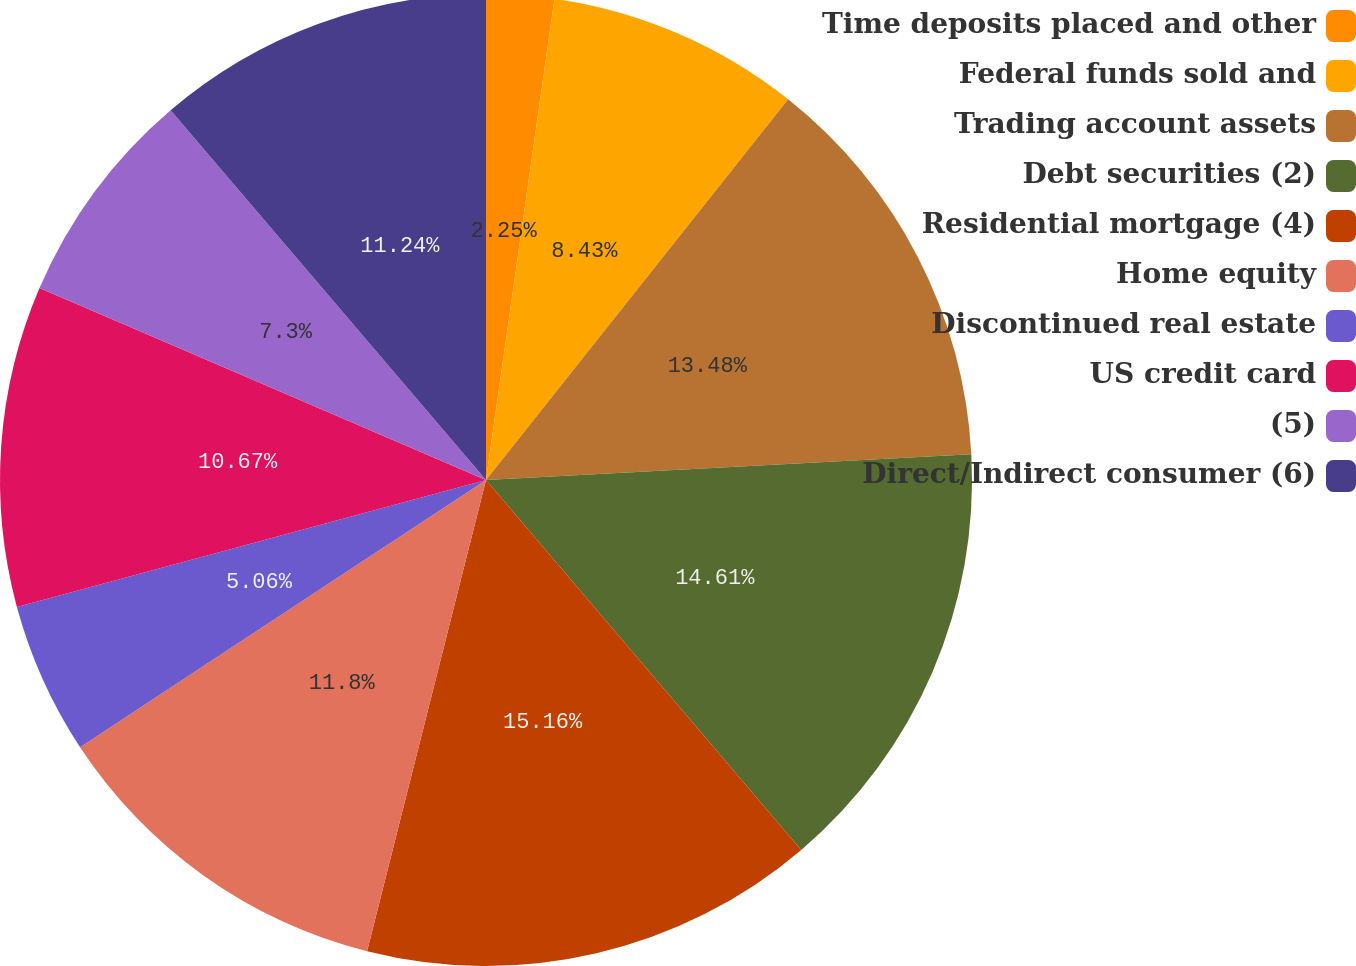Convert chart. <chart><loc_0><loc_0><loc_500><loc_500><pie_chart><fcel>Time deposits placed and other<fcel>Federal funds sold and<fcel>Trading account assets<fcel>Debt securities (2)<fcel>Residential mortgage (4)<fcel>Home equity<fcel>Discontinued real estate<fcel>US credit card<fcel>(5)<fcel>Direct/Indirect consumer (6)<nl><fcel>2.25%<fcel>8.43%<fcel>13.48%<fcel>14.61%<fcel>15.17%<fcel>11.8%<fcel>5.06%<fcel>10.67%<fcel>7.3%<fcel>11.24%<nl></chart> 